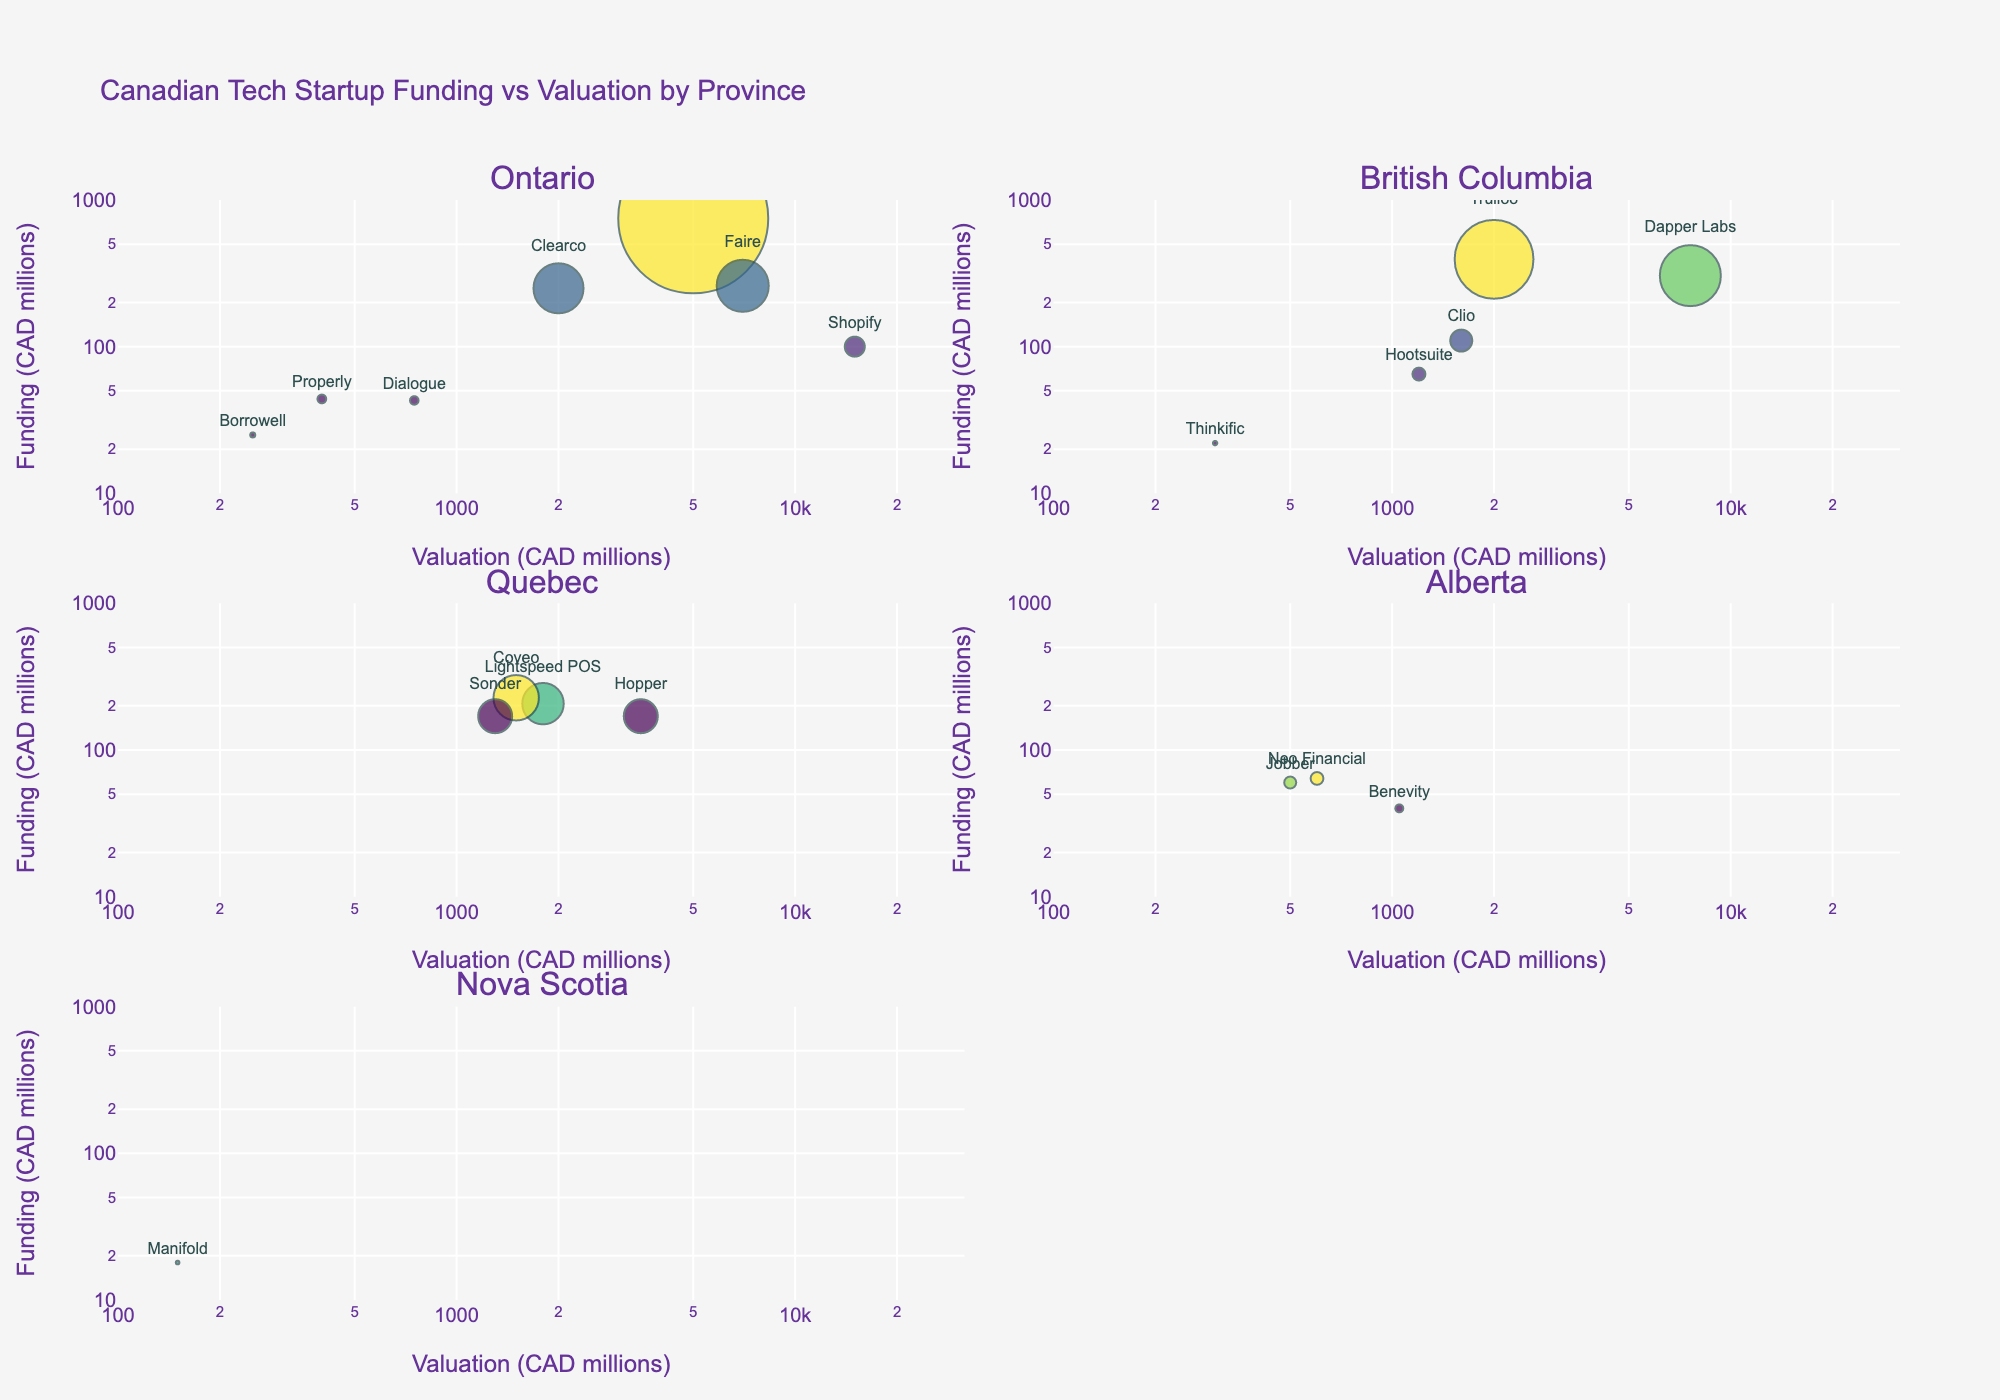What is the title of the overall plot? The title is found at the top center of the plot.
Answer: "Canadian Tech Startup Funding vs Valuation by Province" Which province has the company with the highest funding amount? By scanning all provinces, the company "Wealthsimple" in Ontario has the highest funding amount at $750 million.
Answer: Ontario Which company in Quebec has the highest valuation, and what is its valuation? By looking at the subgroup for Quebec, "Hopper" has the highest valuation of $3500 million.
Answer: Hopper, $3500 million How many companies in British Columbia have a funding amount lower than $100 million? By inspecting the scatter plot for British Columbia, there are three companies: Hootsuite ($65M), Thinkific ($22M), and Clio ($110M), only two have lower than $100 million.
Answer: Two companies Which company in Alberta has the highest valuation? By checking the Alberta subplot, "Benevity" has the highest valuation of $1050 million.
Answer: Benevity What is the color scale used for the scatter plot markers? The plot uses a sequential color scale which can be seen in varying colors for the markers.
Answer: Viridis How many companies in Ontario have valuations greater than $1000 million? By referring to the Ontario subplot, there are five companies greater than $1000 million: Shopify, Wealthsimple, Clearco, Faire, and Borowell.
Answer: Five companies Compare the funding amount of Lightspeed POS and Hopper in Quebec. Which one has more funding? Lightspeed POS has $207 million, while Hopper has $170 million. Therefore, Lightspeed POS has more funding.
Answer: Lightspeed POS has more funding Which company in Nova Scotia is listed, and what is its funding amount? The Nova Scotia subplot shows only one company, "Manifold," with a funding amount of $18 million.
Answer: Manifold, $18 million What is the relationship between the funding and valuation for the startups in British Columbia? Most companies like Clio and Dapper Labs have higher valuations as their funding amounts increase, indicating a positive correlation.
Answer: Positive correlation 